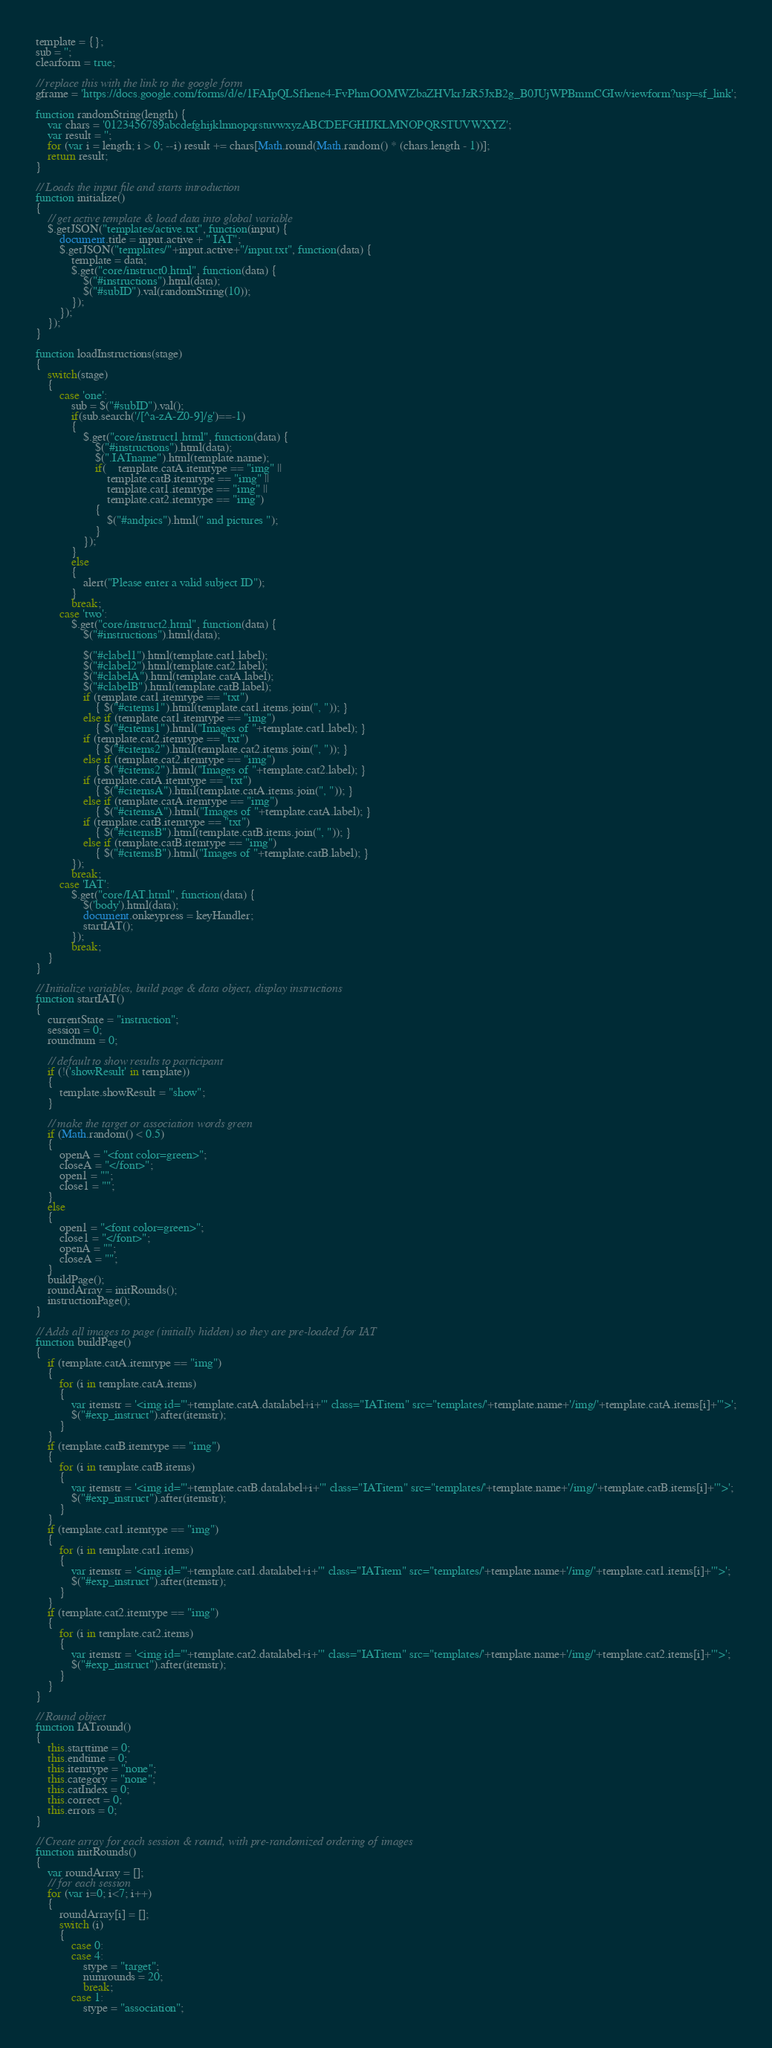Convert code to text. <code><loc_0><loc_0><loc_500><loc_500><_JavaScript_>template = {};
sub = '';
clearform = true;

// replace this with the link to the google form
gframe = 'https://docs.google.com/forms/d/e/1FAIpQLSfhene4-FvPhmOOMWZbaZHVkrJzR5JxB2g_B0JUjWPBmmCGIw/viewform?usp=sf_link';

function randomString(length) {
	var chars = '0123456789abcdefghijklmnopqrstuvwxyzABCDEFGHIJKLMNOPQRSTUVWXYZ';
    var result = '';
    for (var i = length; i > 0; --i) result += chars[Math.round(Math.random() * (chars.length - 1))];
    return result;
}

// Loads the input file and starts introduction
function initialize()
{	
	// get active template & load data into global variable
	$.getJSON("templates/active.txt", function(input) {
		document.title = input.active + " IAT";
		$.getJSON("templates/"+input.active+"/input.txt", function(data) { 
			template = data;
			$.get("core/instruct0.html", function(data) {
				$("#instructions").html(data);
				$("#subID").val(randomString(10));
			});
		});
	});
}

function loadInstructions(stage)
{
	switch(stage)
	{
		case 'one':
			sub = $("#subID").val();
			if(sub.search('/[^a-zA-Z0-9]/g')==-1)
			{
				$.get("core/instruct1.html", function(data) {
					$("#instructions").html(data);
					$(".IATname").html(template.name);
					if(	template.catA.itemtype == "img" || 
						template.catB.itemtype == "img" || 
						template.cat1.itemtype == "img" || 
						template.cat2.itemtype == "img")
					{
						$("#andpics").html(" and pictures ");
					}
				});
			}
			else
			{
				alert("Please enter a valid subject ID");
			}
			break;
		case 'two':
			$.get("core/instruct2.html", function(data) {
				$("#instructions").html(data);
				
				$("#clabel1").html(template.cat1.label);
		        $("#clabel2").html(template.cat2.label);
		        $("#clabelA").html(template.catA.label);
		        $("#clabelB").html(template.catB.label);
		        if (template.cat1.itemtype == "txt")
		            { $("#citems1").html(template.cat1.items.join(", ")); }
		        else if (template.cat1.itemtype == "img")
		            { $("#citems1").html("Images of "+template.cat1.label); }
		        if (template.cat2.itemtype == "txt")
		            { $("#citems2").html(template.cat2.items.join(", ")); }
		        else if (template.cat2.itemtype == "img")
		            { $("#citems2").html("Images of "+template.cat2.label); }
		        if (template.catA.itemtype == "txt")
		            { $("#citemsA").html(template.catA.items.join(", ")); }
		        else if (template.catA.itemtype == "img")
		            { $("#citemsA").html("Images of "+template.catA.label); }
		        if (template.catB.itemtype == "txt")
		            { $("#citemsB").html(template.catB.items.join(", ")); }
		        else if (template.catB.itemtype == "img")
		            { $("#citemsB").html("Images of "+template.catB.label); }
			});
			break;
		case 'IAT':
			$.get("core/IAT.html", function(data) {
				$('body').html(data);
				document.onkeypress = keyHandler; 
				startIAT();
			});
			break;
	}
}

// Initialize variables, build page & data object, display instructions
function startIAT()
{
	currentState = "instruction";
	session = 0;
	roundnum = 0;
	
	// default to show results to participant
	if (!('showResult' in template))
	{
	    template.showResult = "show";
	}
	
	// make the target or association words green
	if (Math.random() < 0.5)
	{
		openA = "<font color=green>";
		closeA = "</font>";
		open1 = "";
		close1 = "";
	}
	else
	{		
		open1 = "<font color=green>";
		close1 = "</font>";
		openA = "";
		closeA = "";
	}
	buildPage();
	roundArray = initRounds();
    instructionPage();
}

// Adds all images to page (initially hidden) so they are pre-loaded for IAT
function buildPage()
{
	if (template.catA.itemtype == "img")
	{
		for (i in template.catA.items)
		{
			var itemstr = '<img id="'+template.catA.datalabel+i+'" class="IATitem" src="templates/'+template.name+'/img/'+template.catA.items[i]+'">';
			$("#exp_instruct").after(itemstr);
		}
	}
	if (template.catB.itemtype == "img")
	{
		for (i in template.catB.items)
		{
			var itemstr = '<img id="'+template.catB.datalabel+i+'" class="IATitem" src="templates/'+template.name+'/img/'+template.catB.items[i]+'">';
			$("#exp_instruct").after(itemstr);
		}
	}
	if (template.cat1.itemtype == "img")
	{
		for (i in template.cat1.items)
		{
			var itemstr = '<img id="'+template.cat1.datalabel+i+'" class="IATitem" src="templates/'+template.name+'/img/'+template.cat1.items[i]+'">';
			$("#exp_instruct").after(itemstr);
		}
	}
	if (template.cat2.itemtype == "img")
	{
		for (i in template.cat2.items)
		{
			var itemstr = '<img id="'+template.cat2.datalabel+i+'" class="IATitem" src="templates/'+template.name+'/img/'+template.cat2.items[i]+'">';
			$("#exp_instruct").after(itemstr);
		}
	}
}

// Round object
function IATround()
{
	this.starttime = 0;
	this.endtime = 0;
	this.itemtype = "none";
	this.category = "none";
	this.catIndex = 0;
	this.correct = 0;
	this.errors = 0;
}

// Create array for each session & round, with pre-randomized ordering of images
function initRounds()
{
    var roundArray = [];
    // for each session
    for (var i=0; i<7; i++)
    {
        roundArray[i] = [];
        switch (i)
        {
            case 0:
            case 4:
                stype = "target";
                numrounds = 20;
                break;
            case 1:    
                stype = "association";</code> 